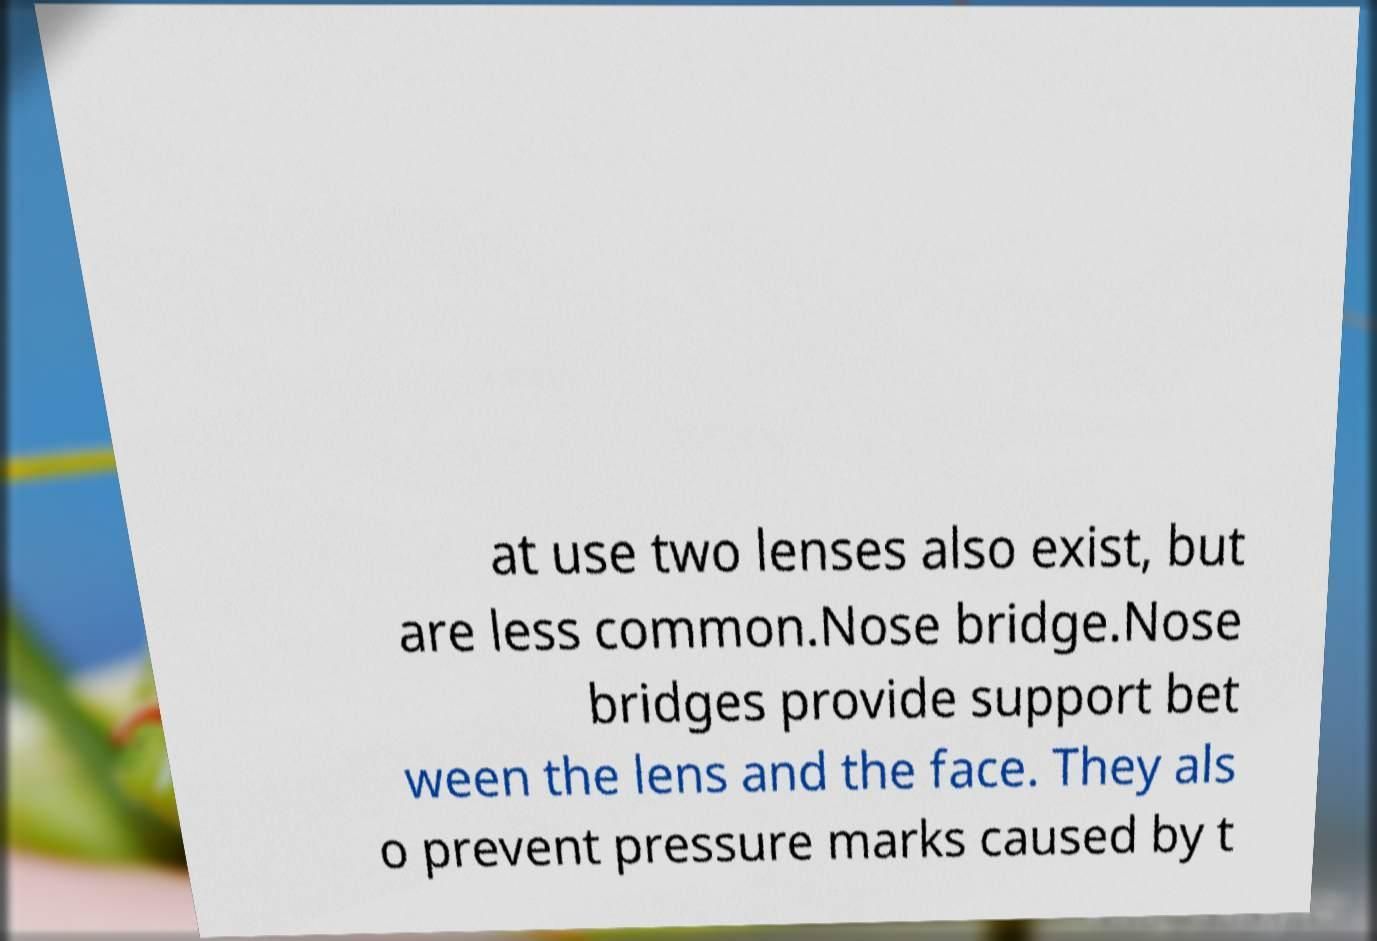Please identify and transcribe the text found in this image. at use two lenses also exist, but are less common.Nose bridge.Nose bridges provide support bet ween the lens and the face. They als o prevent pressure marks caused by t 